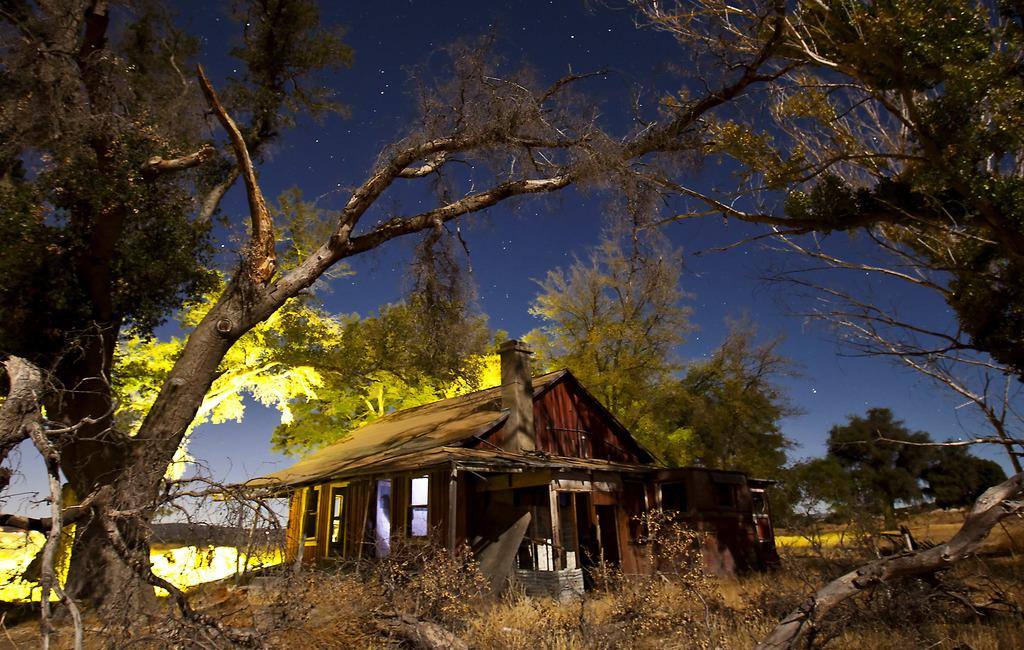What type of structure is present in the picture? There is a house in the picture. What other natural elements can be seen in the picture? There are plants and trees in the picture. What can be seen in the background of the picture? The sky is visible in the background of the picture. Can you see a receipt hanging from the tree in the picture? There is no receipt present in the picture; it only features a house, plants, trees, and the sky. 